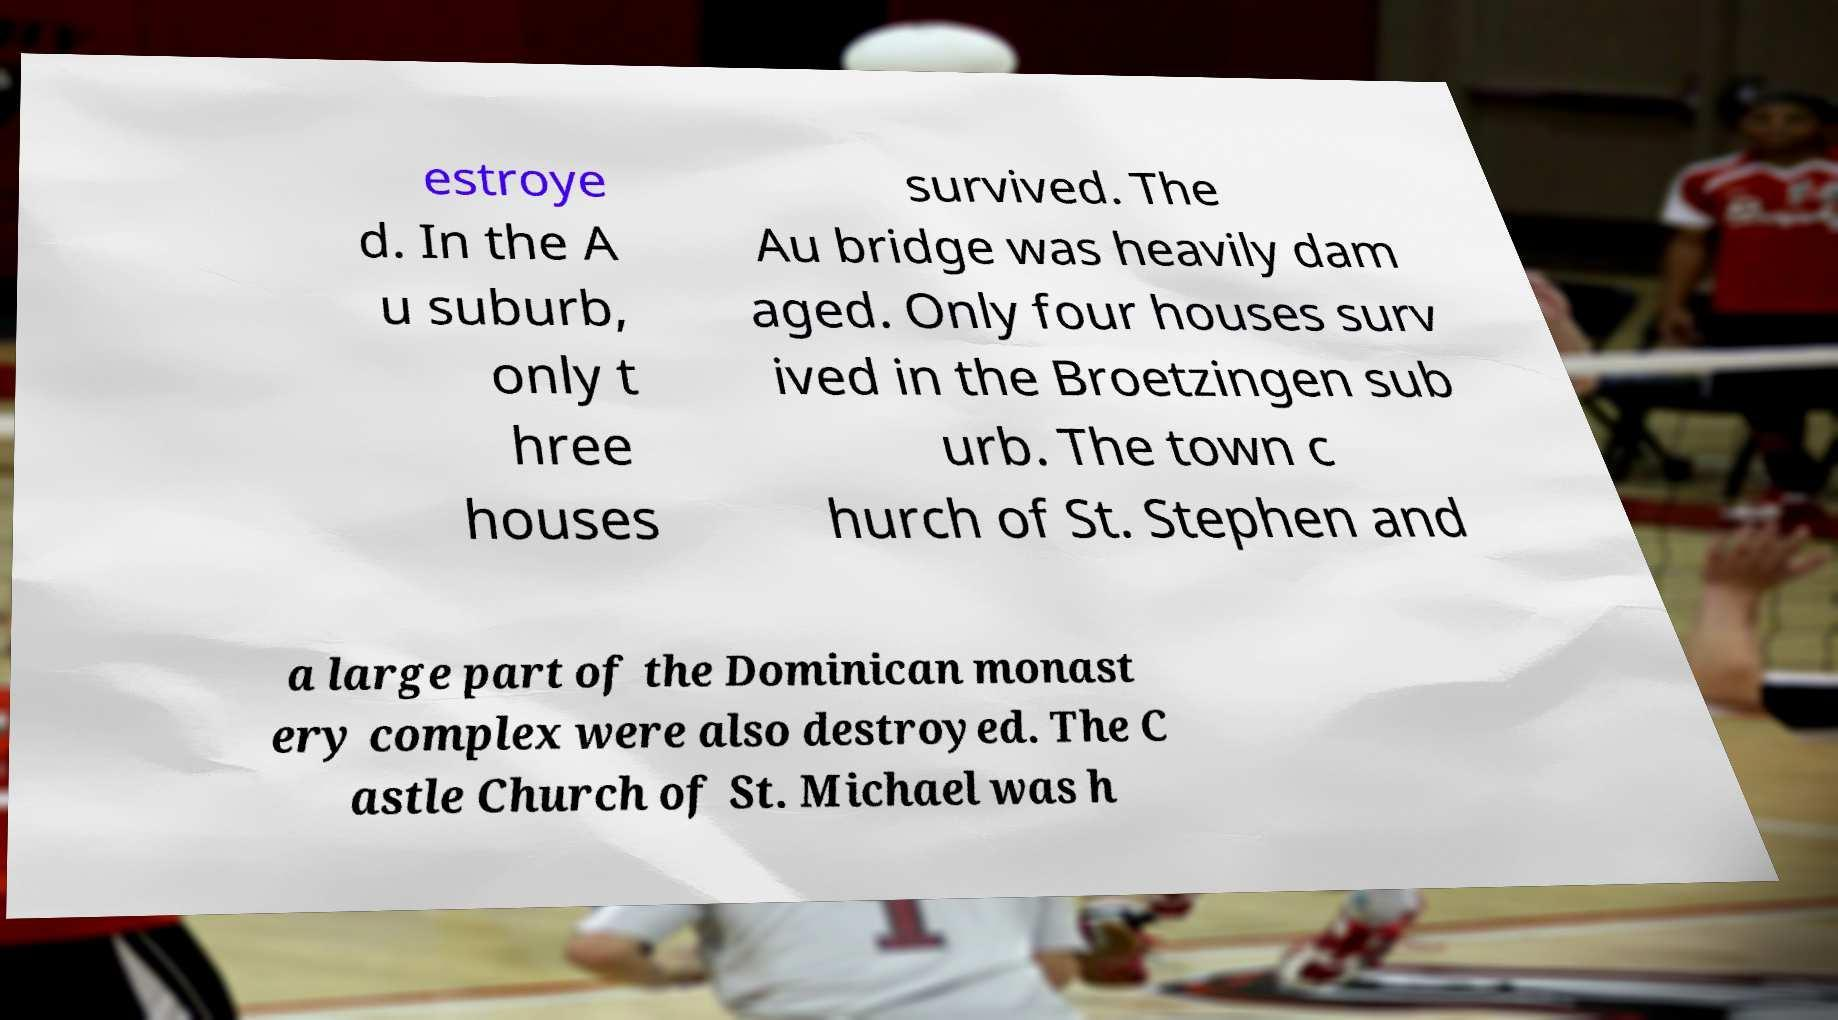For documentation purposes, I need the text within this image transcribed. Could you provide that? estroye d. In the A u suburb, only t hree houses survived. The Au bridge was heavily dam aged. Only four houses surv ived in the Broetzingen sub urb. The town c hurch of St. Stephen and a large part of the Dominican monast ery complex were also destroyed. The C astle Church of St. Michael was h 